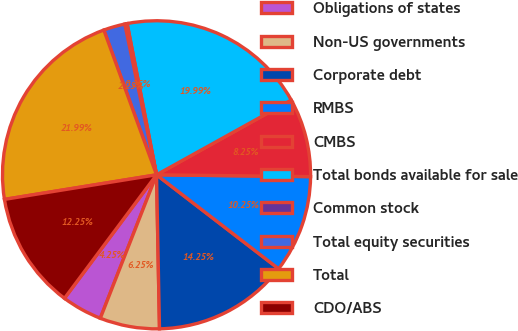Convert chart to OTSL. <chart><loc_0><loc_0><loc_500><loc_500><pie_chart><fcel>Obligations of states<fcel>Non-US governments<fcel>Corporate debt<fcel>RMBS<fcel>CMBS<fcel>Total bonds available for sale<fcel>Common stock<fcel>Total equity securities<fcel>Total<fcel>CDO/ABS<nl><fcel>4.25%<fcel>6.25%<fcel>14.25%<fcel>10.25%<fcel>8.25%<fcel>19.99%<fcel>0.25%<fcel>2.25%<fcel>21.99%<fcel>12.25%<nl></chart> 